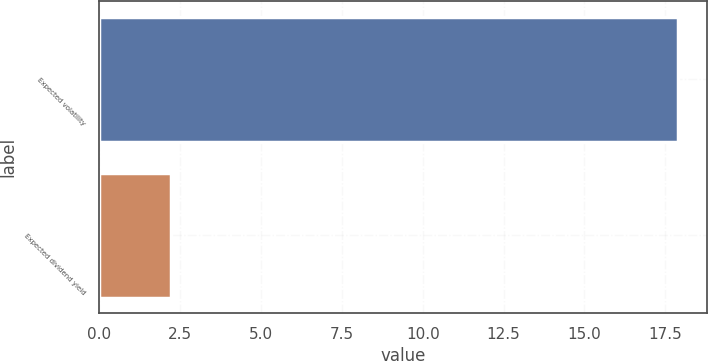<chart> <loc_0><loc_0><loc_500><loc_500><bar_chart><fcel>Expected volatility<fcel>Expected dividend yield<nl><fcel>17.9<fcel>2.2<nl></chart> 